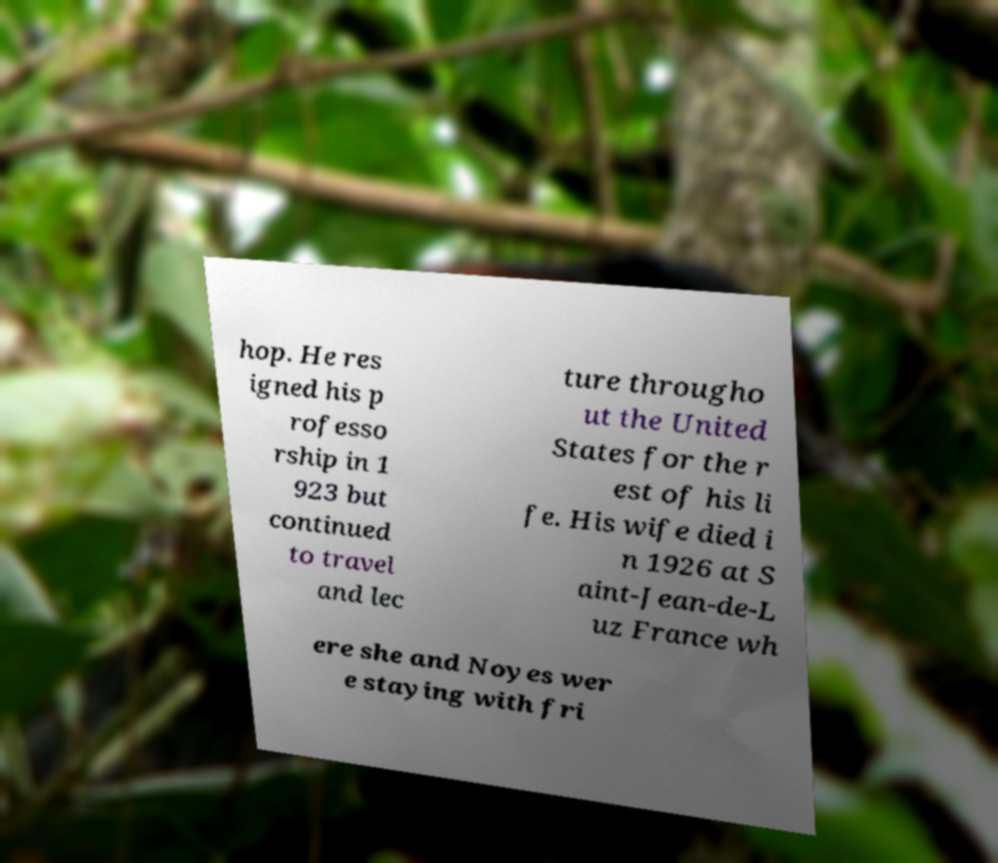What messages or text are displayed in this image? I need them in a readable, typed format. hop. He res igned his p rofesso rship in 1 923 but continued to travel and lec ture througho ut the United States for the r est of his li fe. His wife died i n 1926 at S aint-Jean-de-L uz France wh ere she and Noyes wer e staying with fri 